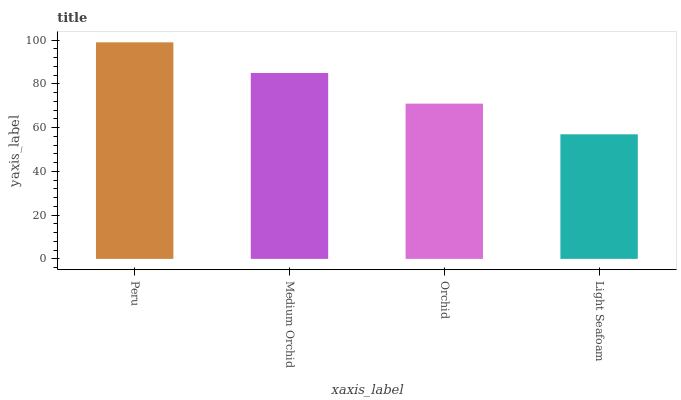Is Light Seafoam the minimum?
Answer yes or no. Yes. Is Peru the maximum?
Answer yes or no. Yes. Is Medium Orchid the minimum?
Answer yes or no. No. Is Medium Orchid the maximum?
Answer yes or no. No. Is Peru greater than Medium Orchid?
Answer yes or no. Yes. Is Medium Orchid less than Peru?
Answer yes or no. Yes. Is Medium Orchid greater than Peru?
Answer yes or no. No. Is Peru less than Medium Orchid?
Answer yes or no. No. Is Medium Orchid the high median?
Answer yes or no. Yes. Is Orchid the low median?
Answer yes or no. Yes. Is Light Seafoam the high median?
Answer yes or no. No. Is Peru the low median?
Answer yes or no. No. 